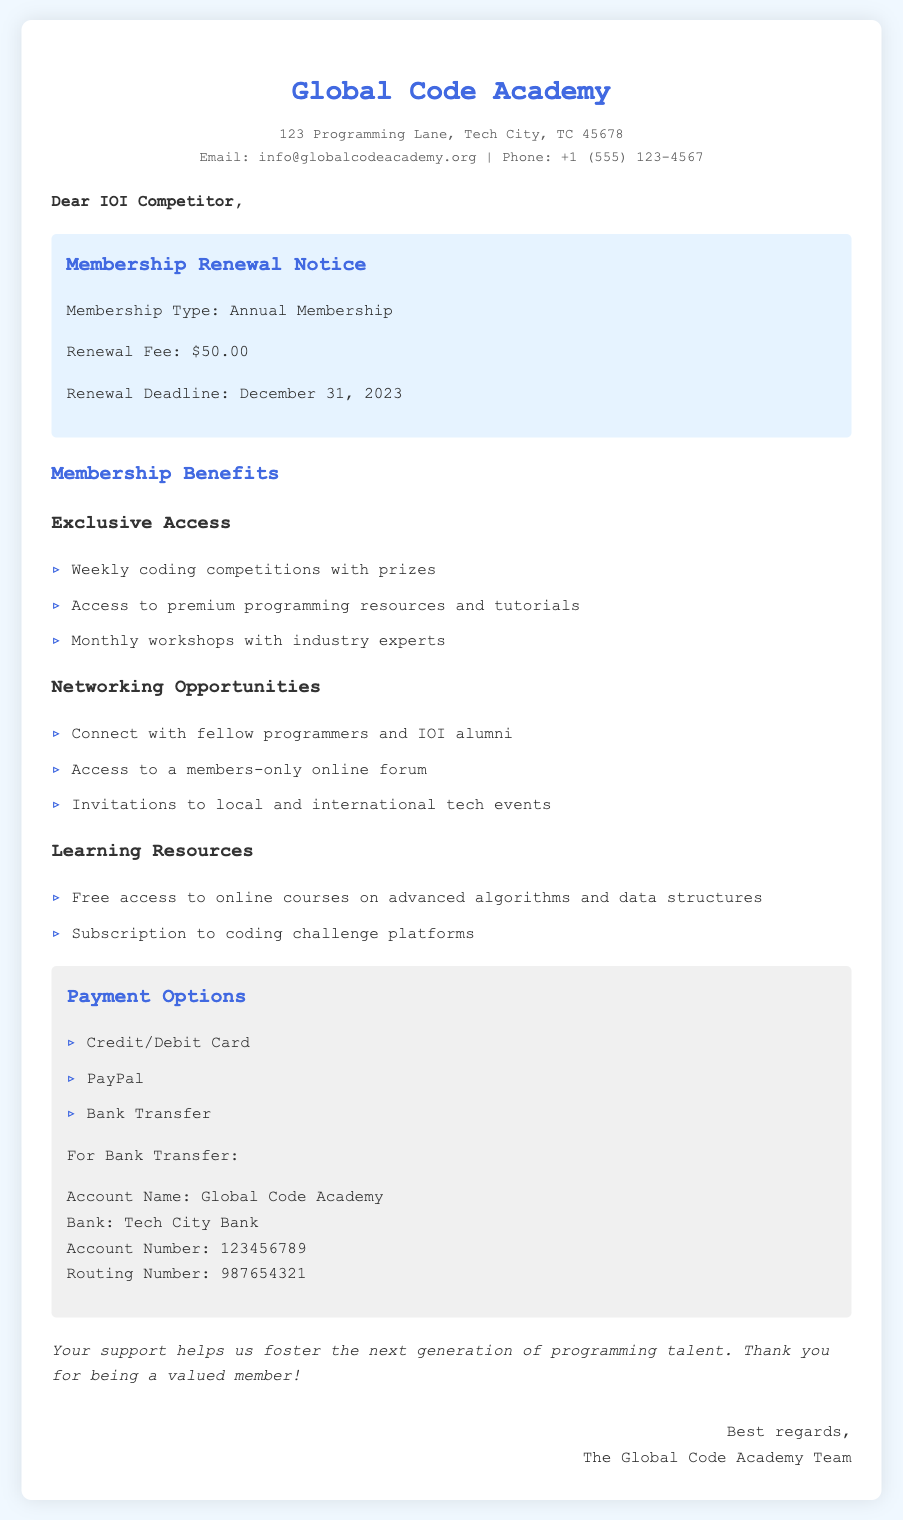What is the membership type? The document specifies that the membership type is "Annual Membership."
Answer: Annual Membership What is the renewal fee? The renewal fee is stated clearly as "$50.00."
Answer: $50.00 What is the renewal deadline? The deadline for renewal is given as "December 31, 2023."
Answer: December 31, 2023 What kind of competitions are offered as a benefit? The document mentions "Weekly coding competitions with prizes" as part of the benefits.
Answer: Weekly coding competitions with prizes What payment options are available? The payment options listed include "Credit/Debit Card, PayPal, Bank Transfer."
Answer: Credit/Debit Card, PayPal, Bank Transfer What should I do for a bank transfer? For bank transfer, the document provides specific account information, indicating the account name as "Global Code Academy."
Answer: Global Code Academy Which city is the Global Code Academy located in? The address indicates that the Global Code Academy is located in "Tech City."
Answer: Tech City Which type of events do members get invited to? Members receive invitations to "local and international tech events."
Answer: local and international tech events What are the learning resources provided? The document details that members can access "free access to online courses on advanced algorithms and data structures" under learning resources.
Answer: free access to online courses on advanced algorithms and data structures 